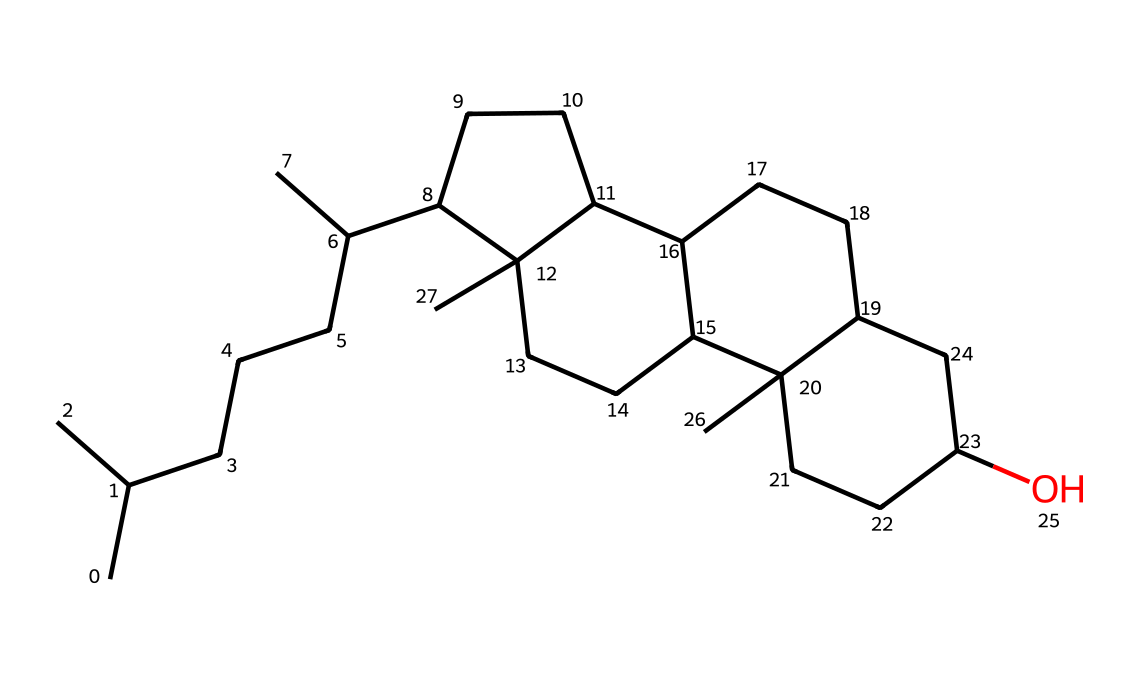What is the chemical name of this structure? The structure represented by the SMILES is known as cholecalciferol, which is the IUPAC name for Vitamin D3. The name corresponds directly to its molecular configuration as determined from the SMILES notation.
Answer: cholecalciferol How many carbon atoms are in this chemical? By analyzing the given SMILES representation, we can count the number of 'C' in the structure. Each distinct carbon atom is represented, and the total counts up to 27 carbon atoms.
Answer: 27 Does this chemical contain any functional groups? Cholecalciferol has a hydroxyl (-OH) functional group, which is indicated by the presence of oxygen in the structure. This group is essential for its biochemical activity in the body, particularly in modulating immune responses.
Answer: yes What is the role of cholecalciferol in the immune system? Cholecalciferol (Vitamin D3) plays a crucial role in enhancing the pathogen-fighting effects of monocytes and macrophages, which are important cells in the immune system that help defend against infections. This is part of its function as a modulator of immune responses.
Answer: immune modulation How does the structure of cholecalciferol influence its biological activity? The three-dimensional arrangement of its carbon skeleton, particularly the presence of the hydroxyl group and specific structural features, allows cholecalciferol to bind effectively to the vitamin D receptor in cells, thereby facilitating its role in gene expression related to immune function.
Answer: structural influence What type of drug classification does cholecalciferol fall under? Cholecalciferol is classified as a vitamin drug, specifically a fat-soluble vitamin. This classification is based on its solubility and its essential role in human nutrition and metabolic processes.
Answer: vitamin drug 